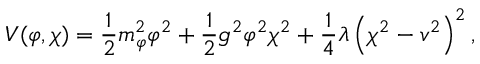Convert formula to latex. <formula><loc_0><loc_0><loc_500><loc_500>V ( \varphi , \chi ) = \frac { 1 } { 2 } m _ { \varphi } ^ { 2 } \varphi ^ { 2 } + \frac { 1 } { 2 } g ^ { 2 } \varphi ^ { 2 } \chi ^ { 2 } + \frac { 1 } { 4 } \lambda \left ( \chi ^ { 2 } - v ^ { 2 } \right ) ^ { 2 } ,</formula> 